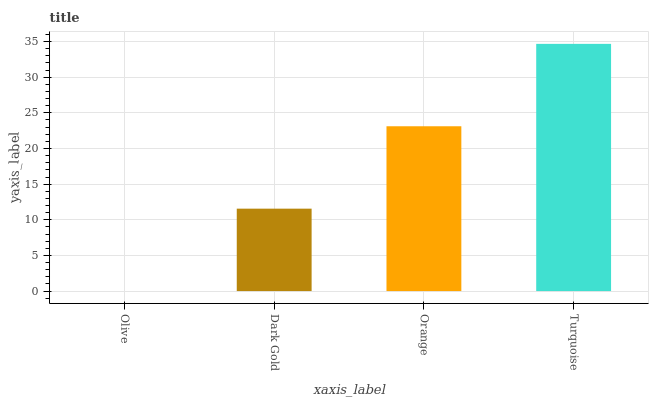Is Olive the minimum?
Answer yes or no. Yes. Is Turquoise the maximum?
Answer yes or no. Yes. Is Dark Gold the minimum?
Answer yes or no. No. Is Dark Gold the maximum?
Answer yes or no. No. Is Dark Gold greater than Olive?
Answer yes or no. Yes. Is Olive less than Dark Gold?
Answer yes or no. Yes. Is Olive greater than Dark Gold?
Answer yes or no. No. Is Dark Gold less than Olive?
Answer yes or no. No. Is Orange the high median?
Answer yes or no. Yes. Is Dark Gold the low median?
Answer yes or no. Yes. Is Dark Gold the high median?
Answer yes or no. No. Is Turquoise the low median?
Answer yes or no. No. 